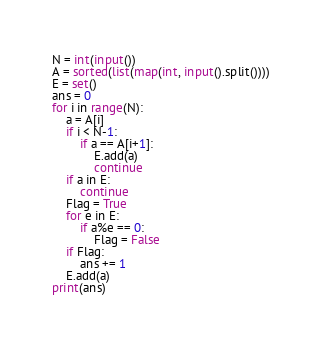<code> <loc_0><loc_0><loc_500><loc_500><_Python_>N = int(input())
A = sorted(list(map(int, input().split())))
E = set()
ans = 0
for i in range(N):
    a = A[i]
    if i < N-1:
        if a == A[i+1]:
            E.add(a)
            continue
    if a in E:
        continue
    Flag = True
    for e in E:
        if a%e == 0:
            Flag = False
    if Flag:
        ans += 1
    E.add(a)
print(ans)</code> 